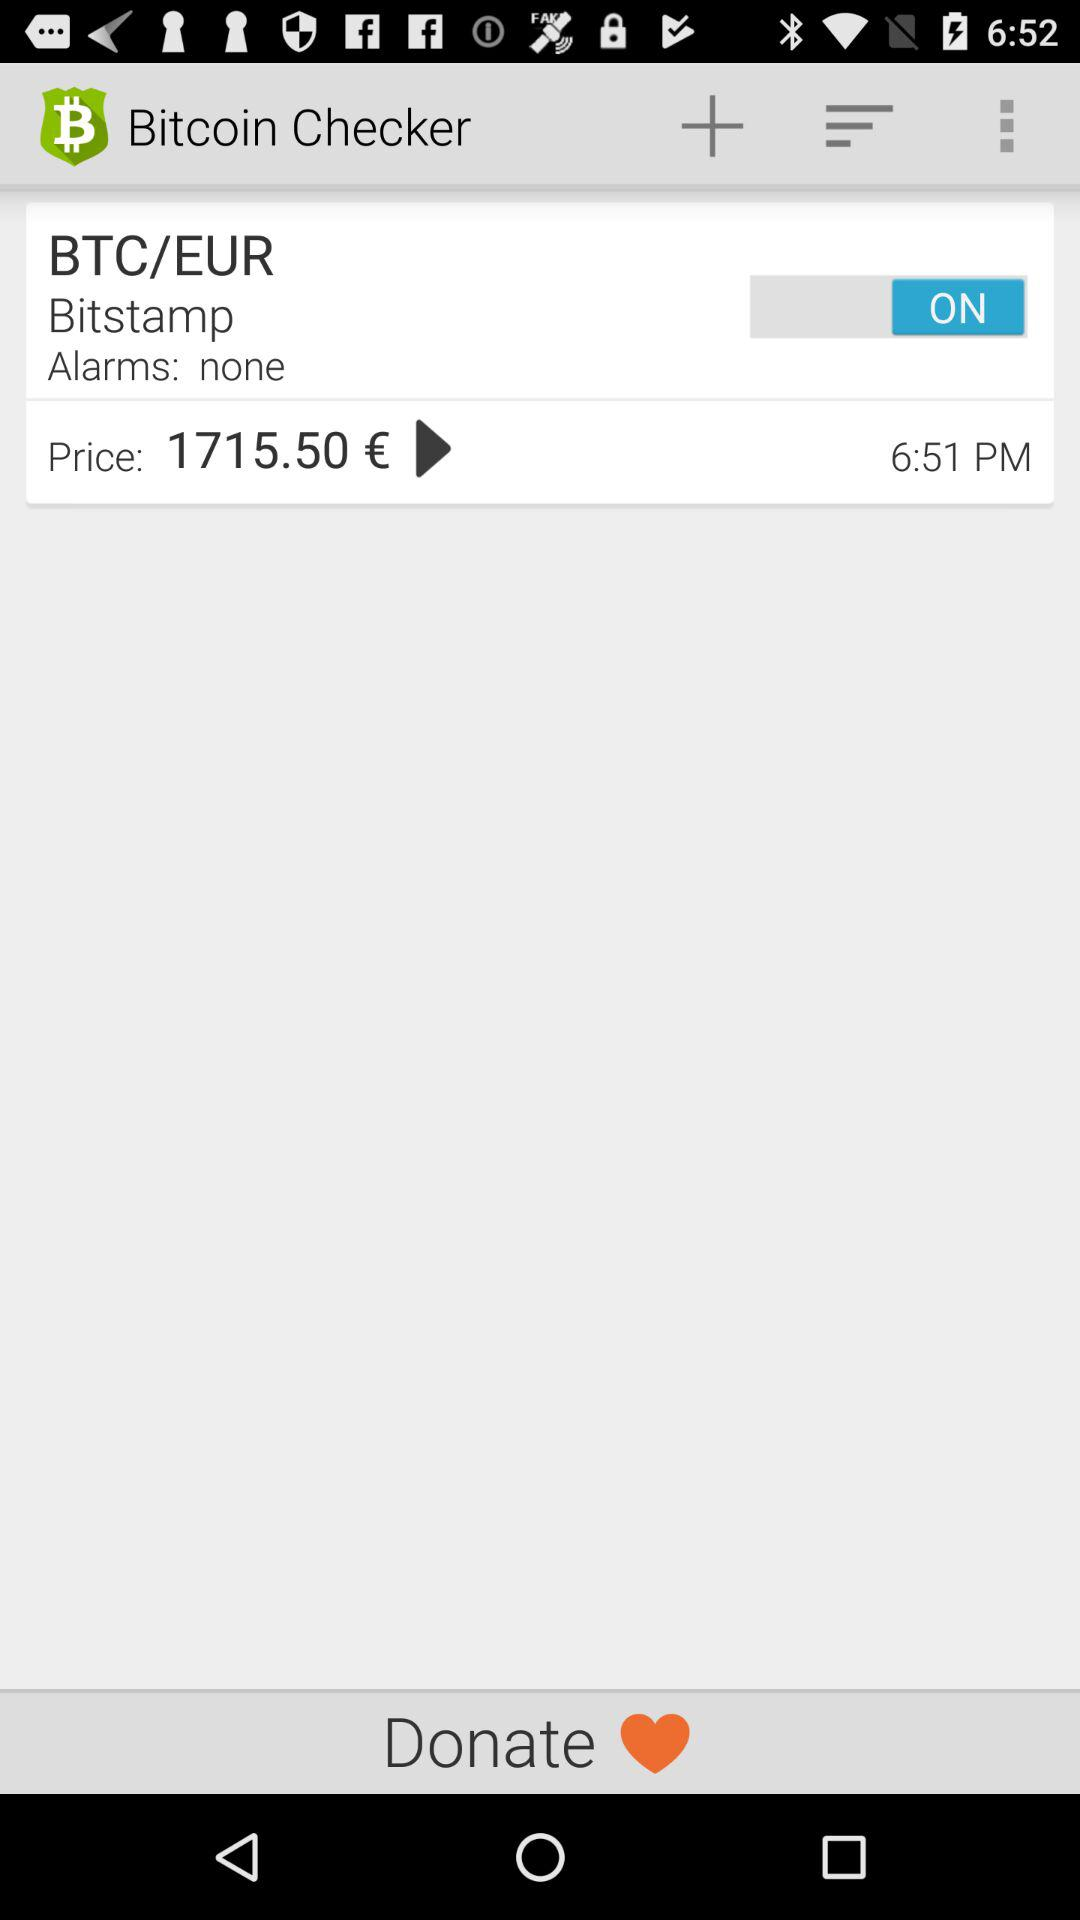What is the status of "BTC/EUR"? The status of "BTC/EUR" is "on". 